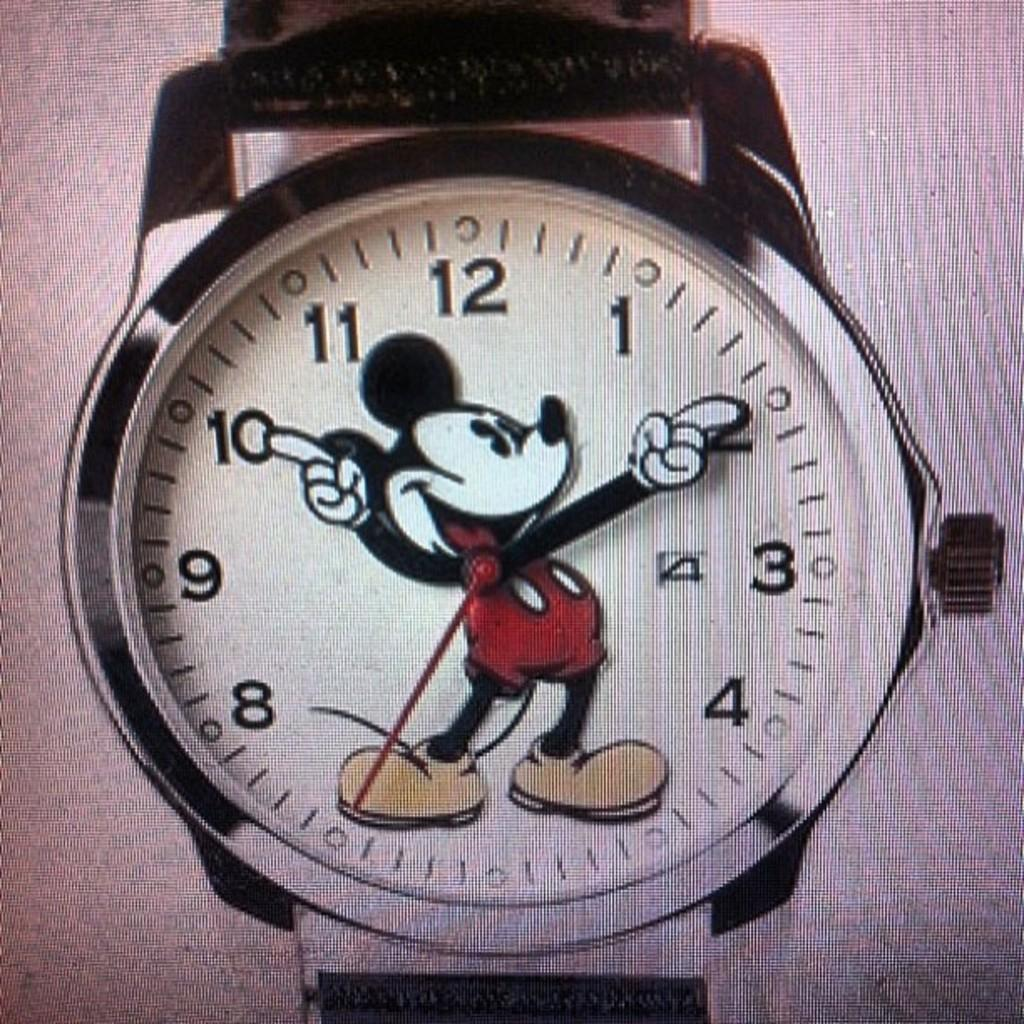What object in the image tells time? There is a watch in the image that tells time. What type of character can be seen in the image? There is a cartoon character in the image. What feature is present on the watch? The watch has numbers on it. How many babies are playing with the art on the farm in the image? There are no babies, art, or farm present in the image. 